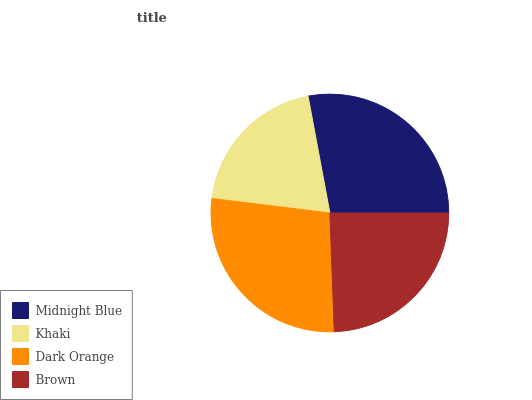Is Khaki the minimum?
Answer yes or no. Yes. Is Midnight Blue the maximum?
Answer yes or no. Yes. Is Dark Orange the minimum?
Answer yes or no. No. Is Dark Orange the maximum?
Answer yes or no. No. Is Dark Orange greater than Khaki?
Answer yes or no. Yes. Is Khaki less than Dark Orange?
Answer yes or no. Yes. Is Khaki greater than Dark Orange?
Answer yes or no. No. Is Dark Orange less than Khaki?
Answer yes or no. No. Is Dark Orange the high median?
Answer yes or no. Yes. Is Brown the low median?
Answer yes or no. Yes. Is Khaki the high median?
Answer yes or no. No. Is Dark Orange the low median?
Answer yes or no. No. 